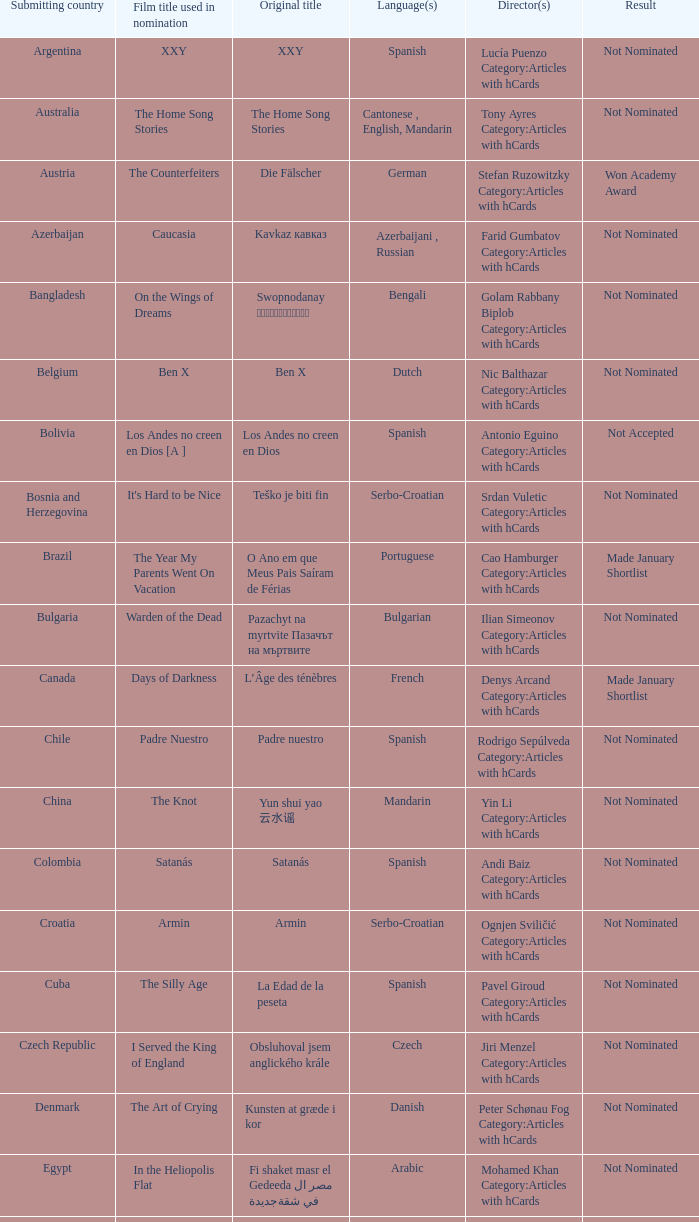Can you provide the title of the movie that came from lebanon? Caramel. 